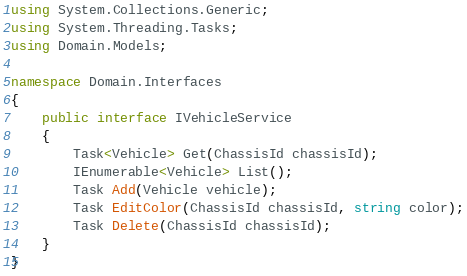Convert code to text. <code><loc_0><loc_0><loc_500><loc_500><_C#_>using System.Collections.Generic;
using System.Threading.Tasks;
using Domain.Models;

namespace Domain.Interfaces
{
    public interface IVehicleService
    {
        Task<Vehicle> Get(ChassisId chassisId);
        IEnumerable<Vehicle> List();
        Task Add(Vehicle vehicle);
        Task EditColor(ChassisId chassisId, string color);
        Task Delete(ChassisId chassisId);
    }
}</code> 